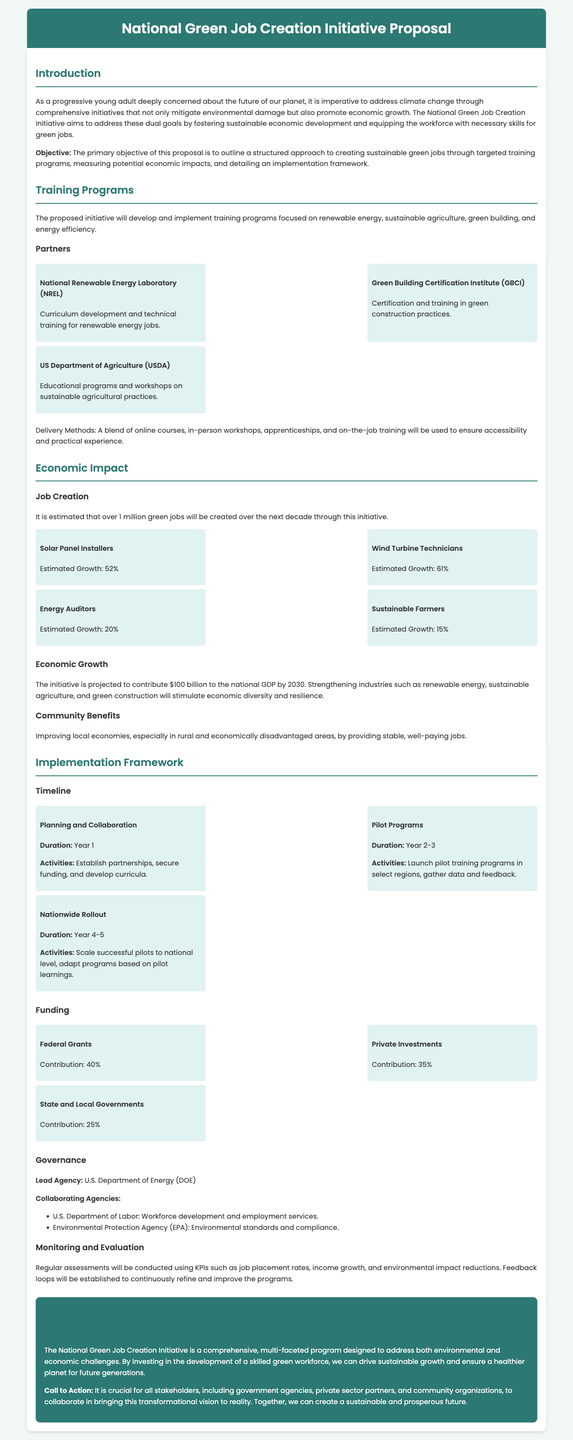What is the primary objective of the proposal? The primary objective is to outline a structured approach to creating sustainable green jobs through targeted training programs.
Answer: To outline a structured approach to creating sustainable green jobs through targeted training programs How many green jobs are expected to be created? The document states that over 1 million green jobs will be created over the next decade.
Answer: Over 1 million Which agency is the lead for this initiative? The lead agency for this initiative is indicated as the U.S. Department of Energy.
Answer: U.S. Department of Energy What is the estimated contribution of the initiative to the national GDP by 2030? The document mentions a projected contribution of $100 billion to the national GDP by 2030.
Answer: $100 billion What is one type of job expected to see a 61% growth? The document lists Wind Turbine Technicians as having an estimated growth of 61%.
Answer: Wind Turbine Technicians How long is the planning phase expected to last? The planning phase is anticipated to last one year, as stated in the timeline.
Answer: Year 1 Which organization is responsible for certification in green construction practices? The Green Building Certification Institute (GBCI) is responsible for certification in green construction practices.
Answer: Green Building Certification Institute (GBCI) What are the funding contributions from private investments? The document specifies that private investments will contribute 35% to the funding.
Answer: 35% What delivery methods will be used in the training programs? The delivery methods will include online courses, in-person workshops, apprenticeships, and on-the-job training.
Answer: Online courses, in-person workshops, apprenticeships, and on-the-job training 